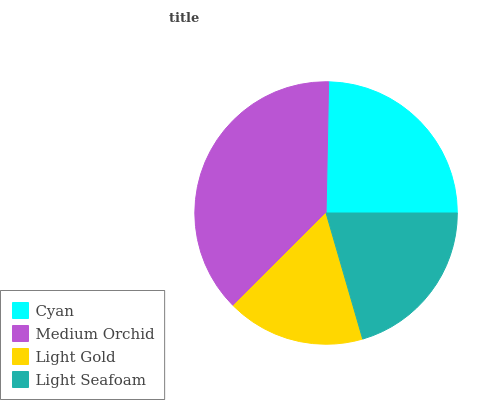Is Light Gold the minimum?
Answer yes or no. Yes. Is Medium Orchid the maximum?
Answer yes or no. Yes. Is Medium Orchid the minimum?
Answer yes or no. No. Is Light Gold the maximum?
Answer yes or no. No. Is Medium Orchid greater than Light Gold?
Answer yes or no. Yes. Is Light Gold less than Medium Orchid?
Answer yes or no. Yes. Is Light Gold greater than Medium Orchid?
Answer yes or no. No. Is Medium Orchid less than Light Gold?
Answer yes or no. No. Is Cyan the high median?
Answer yes or no. Yes. Is Light Seafoam the low median?
Answer yes or no. Yes. Is Light Seafoam the high median?
Answer yes or no. No. Is Light Gold the low median?
Answer yes or no. No. 